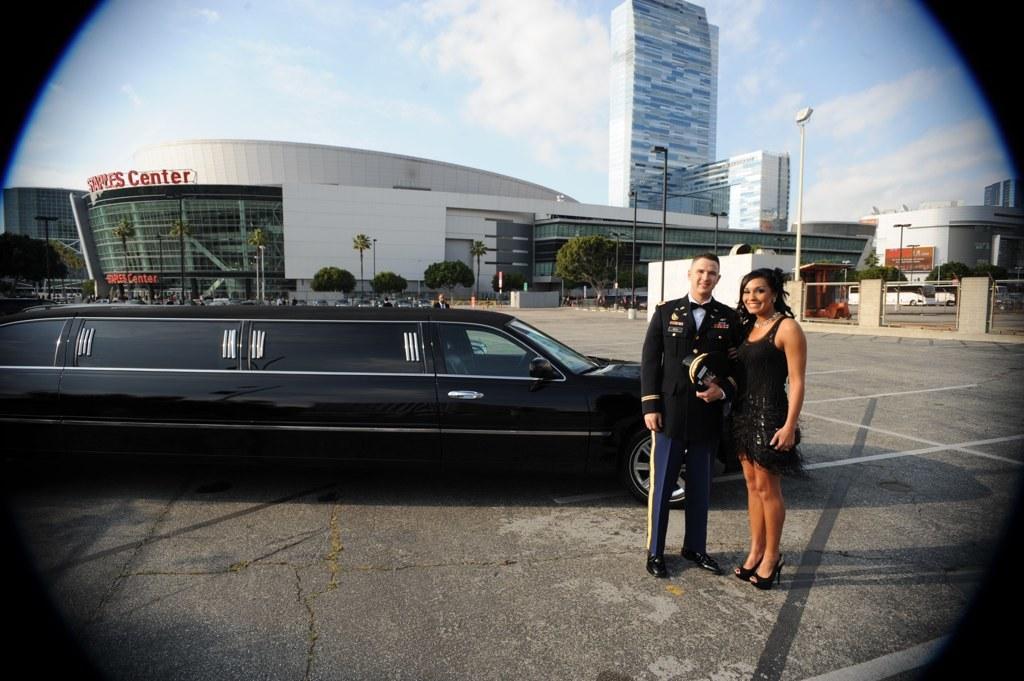In one or two sentences, can you explain what this image depicts? In this picture I can see a man and a woman in front and I see that they're smiling. I can also see that they're standing in front of a car. In the background I can see the buildings, light poles, trees and the sky. 